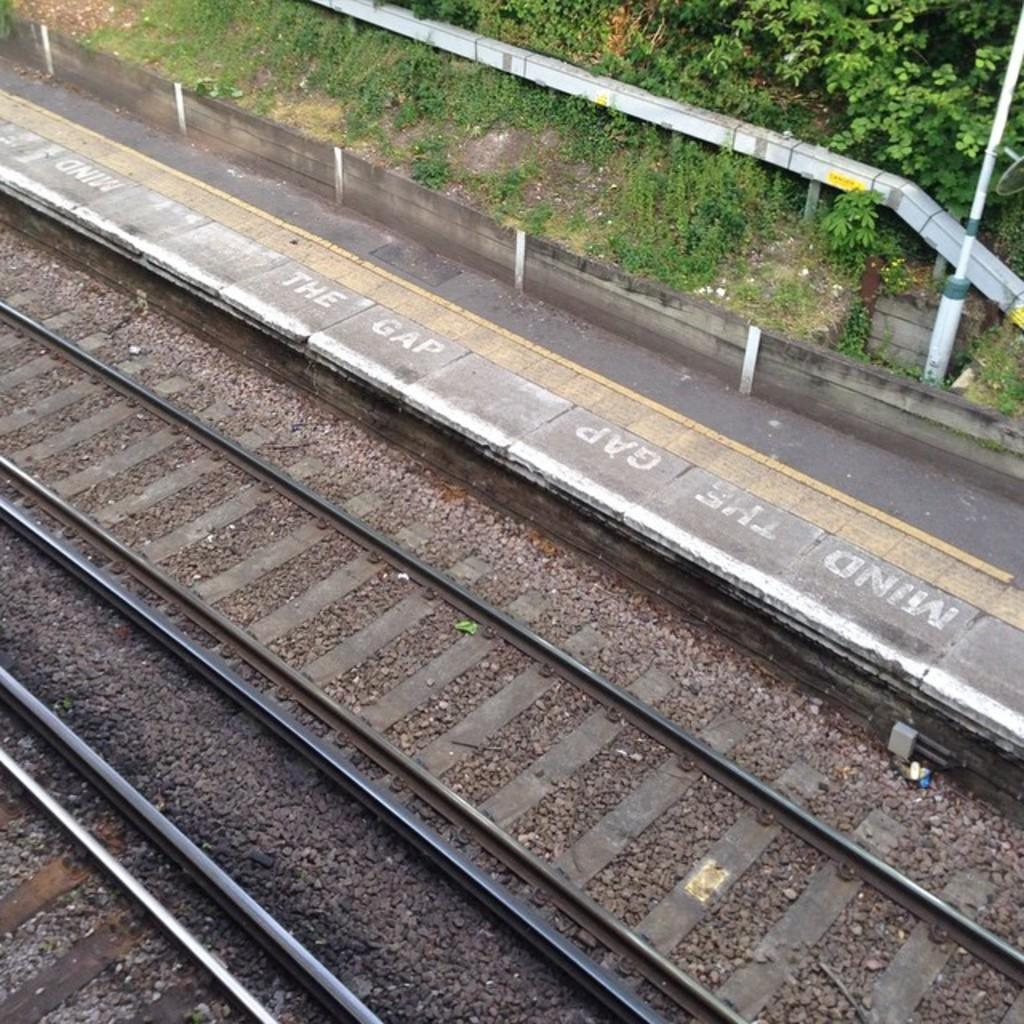What type of surface can be seen in the image? There are tracks in the image. What other elements can be seen on the ground? There are stones visible in the image. What is the natural environment like in the image? The ground is visible, and there is grass and plants present in the image. What structure can be seen in the image? There is a pole in the image. What direction is the daughter facing in the image? There is no daughter present in the image. 